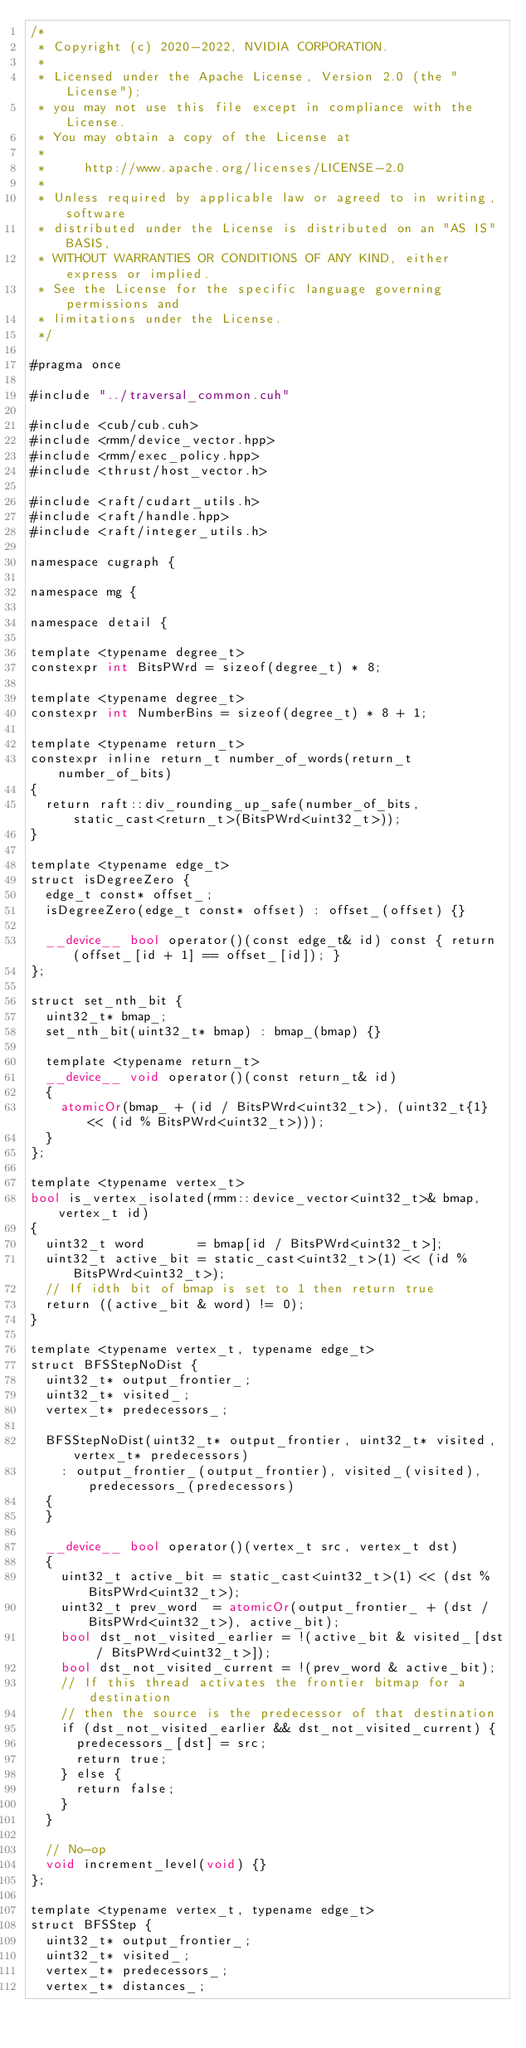Convert code to text. <code><loc_0><loc_0><loc_500><loc_500><_Cuda_>/*
 * Copyright (c) 2020-2022, NVIDIA CORPORATION.
 *
 * Licensed under the Apache License, Version 2.0 (the "License");
 * you may not use this file except in compliance with the License.
 * You may obtain a copy of the License at
 *
 *     http://www.apache.org/licenses/LICENSE-2.0
 *
 * Unless required by applicable law or agreed to in writing, software
 * distributed under the License is distributed on an "AS IS" BASIS,
 * WITHOUT WARRANTIES OR CONDITIONS OF ANY KIND, either express or implied.
 * See the License for the specific language governing permissions and
 * limitations under the License.
 */

#pragma once

#include "../traversal_common.cuh"

#include <cub/cub.cuh>
#include <rmm/device_vector.hpp>
#include <rmm/exec_policy.hpp>
#include <thrust/host_vector.h>

#include <raft/cudart_utils.h>
#include <raft/handle.hpp>
#include <raft/integer_utils.h>

namespace cugraph {

namespace mg {

namespace detail {

template <typename degree_t>
constexpr int BitsPWrd = sizeof(degree_t) * 8;

template <typename degree_t>
constexpr int NumberBins = sizeof(degree_t) * 8 + 1;

template <typename return_t>
constexpr inline return_t number_of_words(return_t number_of_bits)
{
  return raft::div_rounding_up_safe(number_of_bits, static_cast<return_t>(BitsPWrd<uint32_t>));
}

template <typename edge_t>
struct isDegreeZero {
  edge_t const* offset_;
  isDegreeZero(edge_t const* offset) : offset_(offset) {}

  __device__ bool operator()(const edge_t& id) const { return (offset_[id + 1] == offset_[id]); }
};

struct set_nth_bit {
  uint32_t* bmap_;
  set_nth_bit(uint32_t* bmap) : bmap_(bmap) {}

  template <typename return_t>
  __device__ void operator()(const return_t& id)
  {
    atomicOr(bmap_ + (id / BitsPWrd<uint32_t>), (uint32_t{1} << (id % BitsPWrd<uint32_t>)));
  }
};

template <typename vertex_t>
bool is_vertex_isolated(rmm::device_vector<uint32_t>& bmap, vertex_t id)
{
  uint32_t word       = bmap[id / BitsPWrd<uint32_t>];
  uint32_t active_bit = static_cast<uint32_t>(1) << (id % BitsPWrd<uint32_t>);
  // If idth bit of bmap is set to 1 then return true
  return ((active_bit & word) != 0);
}

template <typename vertex_t, typename edge_t>
struct BFSStepNoDist {
  uint32_t* output_frontier_;
  uint32_t* visited_;
  vertex_t* predecessors_;

  BFSStepNoDist(uint32_t* output_frontier, uint32_t* visited, vertex_t* predecessors)
    : output_frontier_(output_frontier), visited_(visited), predecessors_(predecessors)
  {
  }

  __device__ bool operator()(vertex_t src, vertex_t dst)
  {
    uint32_t active_bit = static_cast<uint32_t>(1) << (dst % BitsPWrd<uint32_t>);
    uint32_t prev_word  = atomicOr(output_frontier_ + (dst / BitsPWrd<uint32_t>), active_bit);
    bool dst_not_visited_earlier = !(active_bit & visited_[dst / BitsPWrd<uint32_t>]);
    bool dst_not_visited_current = !(prev_word & active_bit);
    // If this thread activates the frontier bitmap for a destination
    // then the source is the predecessor of that destination
    if (dst_not_visited_earlier && dst_not_visited_current) {
      predecessors_[dst] = src;
      return true;
    } else {
      return false;
    }
  }

  // No-op
  void increment_level(void) {}
};

template <typename vertex_t, typename edge_t>
struct BFSStep {
  uint32_t* output_frontier_;
  uint32_t* visited_;
  vertex_t* predecessors_;
  vertex_t* distances_;</code> 